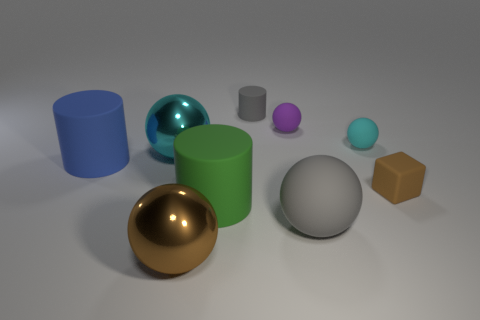Which of the objects in the image stands out the most to you? The large, glossy gold ball stands out due to its reflective surface and prominent size relative to the other objects. 